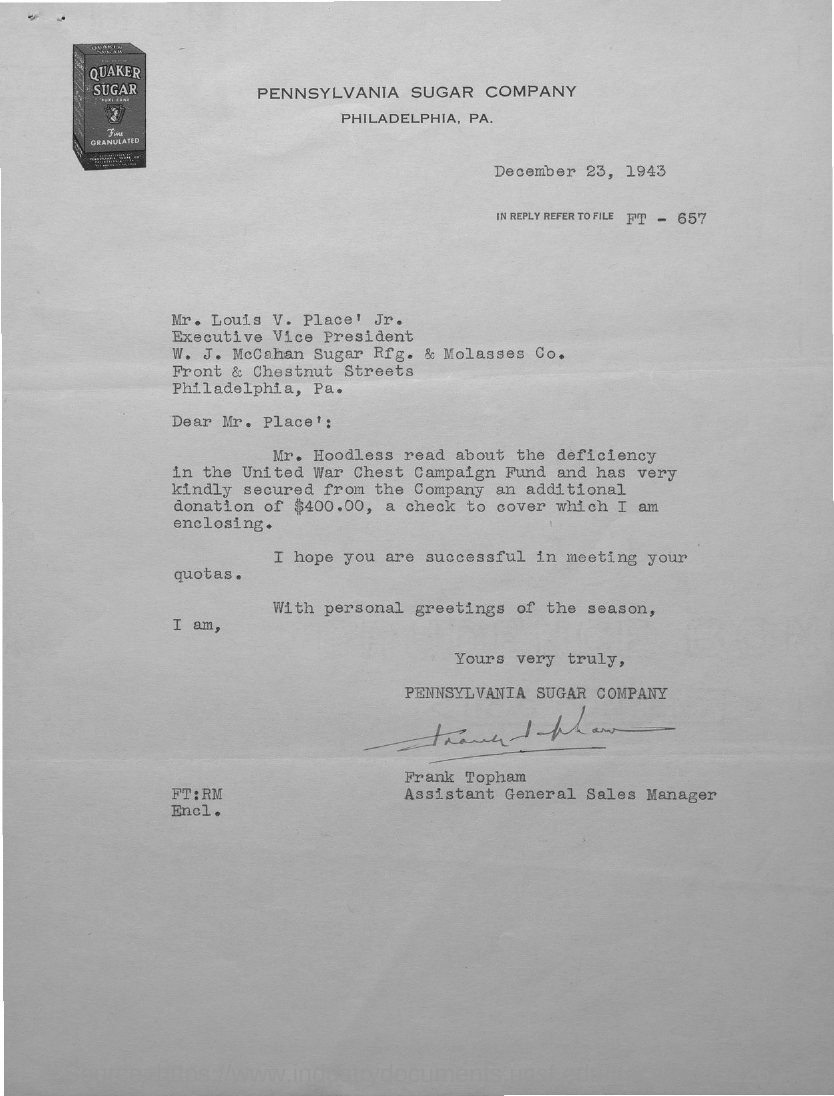Which company is mentioned in the letterhead?
Offer a terse response. Pennsylvania Sugar Company. What is the issued date of this letter?
Your response must be concise. December 23, 1943. Which file is to be referred in reply?
Provide a short and direct response. FT - 657. Who is the sender of this letter?
Your response must be concise. Frank Topham. What is the designation of Frank Topham?
Provide a succinct answer. Assistant General Sales Manager. Who is the addressee of this letter?
Your answer should be compact. Mr. Louis V. Place' Jr. What is the designation of Mr. Louis V. Place' Jr.?
Ensure brevity in your answer.  Executive Vice President. 